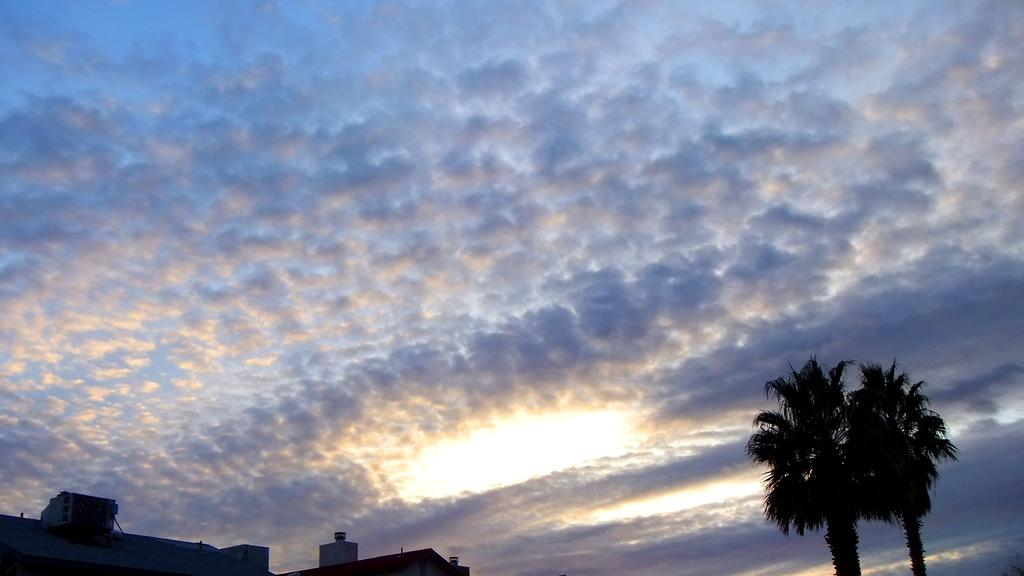What type of vegetation is on the right side of the image? There are trees on the right side of the image. What type of structures are on the left side of the image? There are houses on the left side of the image. What is the condition of the sky in the image? The sky is fully covered with clouds. How many cards are being played by the friends in the image? There are no cards or friends present in the image; it features trees and houses with a cloudy sky. What type of bean is growing on the trees in the image? There are no beans growing on the trees in the image; they are regular trees with leaves. 